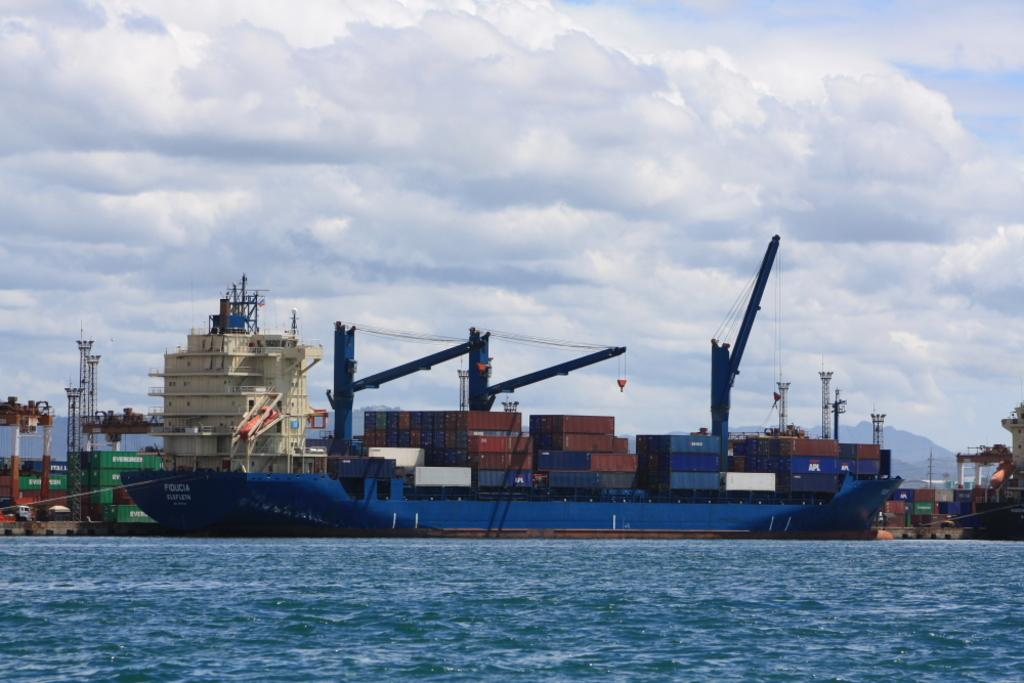What is the main subject of the image? The main subject of the image is a ship. Where is the ship located in the image? The ship is on the water in the image. What else can be seen in the image besides the ship? There are containers, rods with wires, a building, and the sky visible in the image. How does the ship plan to attack the building in the image? There is no indication in the image that the ship is planning an attack on the building, nor is there any evidence of weaponry or hostile intent. 